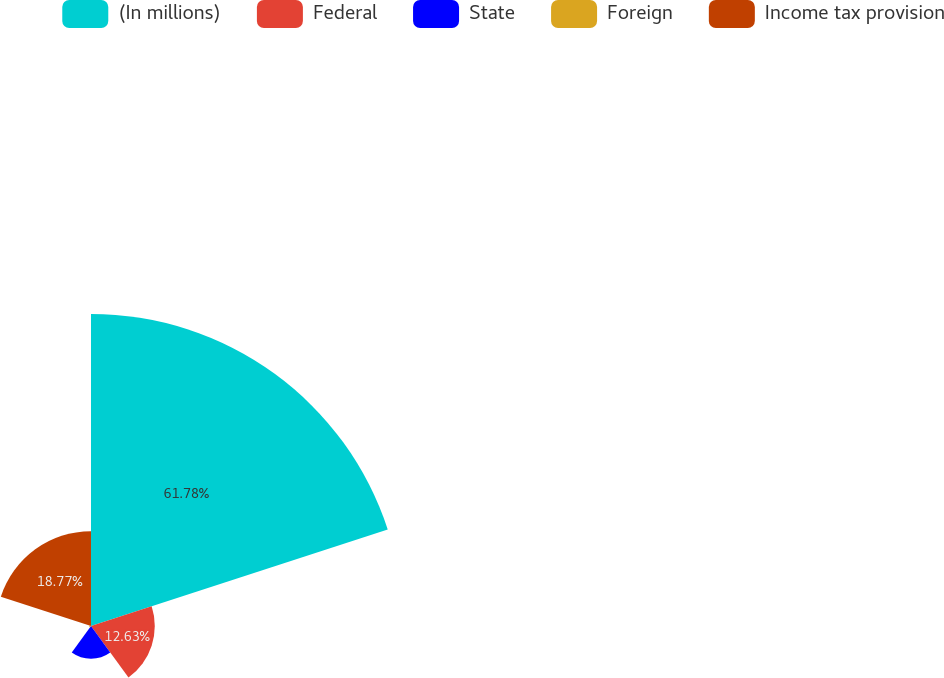Convert chart. <chart><loc_0><loc_0><loc_500><loc_500><pie_chart><fcel>(In millions)<fcel>Federal<fcel>State<fcel>Foreign<fcel>Income tax provision<nl><fcel>61.78%<fcel>12.63%<fcel>6.48%<fcel>0.34%<fcel>18.77%<nl></chart> 